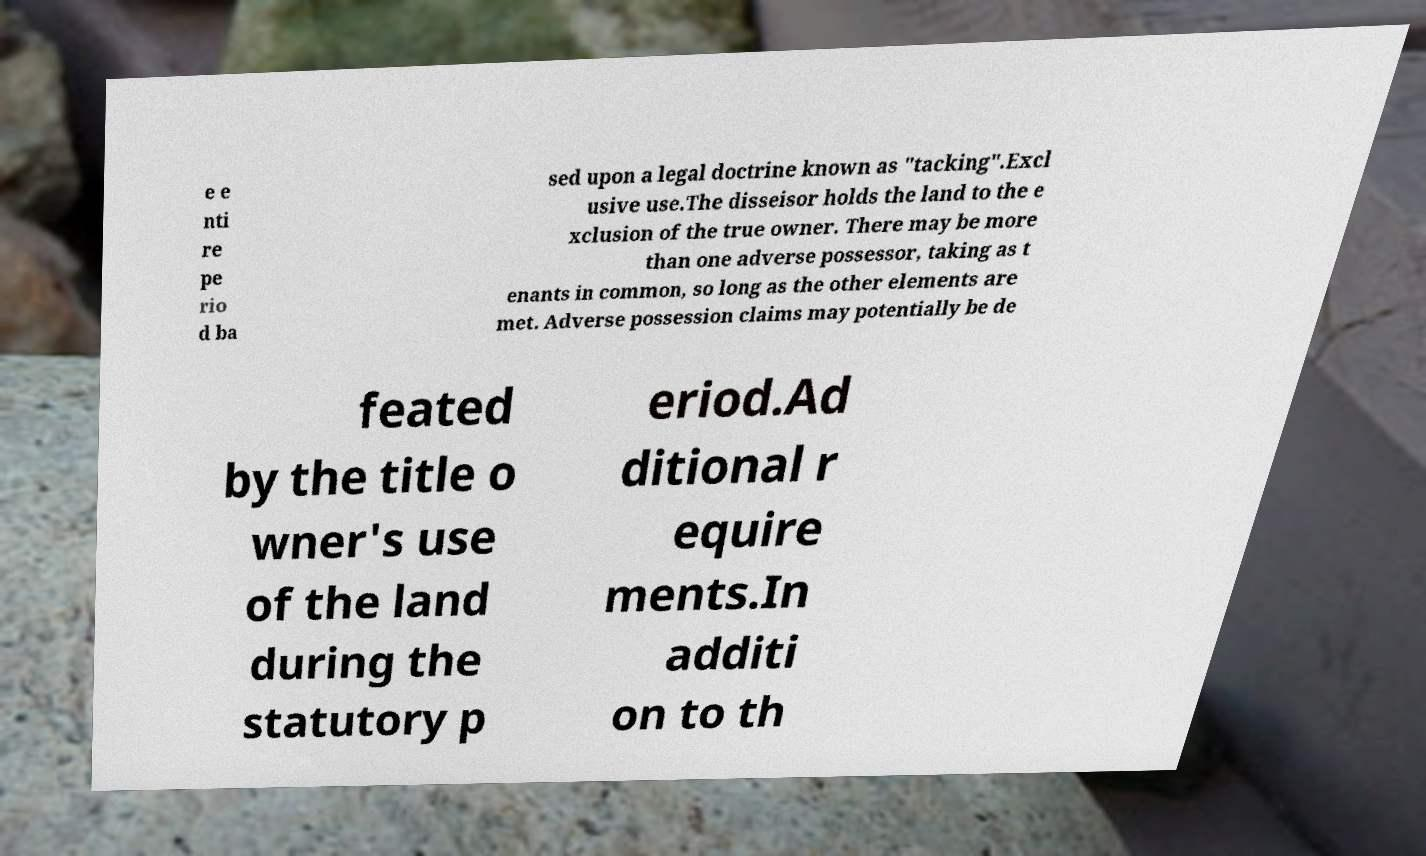Can you accurately transcribe the text from the provided image for me? e e nti re pe rio d ba sed upon a legal doctrine known as "tacking".Excl usive use.The disseisor holds the land to the e xclusion of the true owner. There may be more than one adverse possessor, taking as t enants in common, so long as the other elements are met. Adverse possession claims may potentially be de feated by the title o wner's use of the land during the statutory p eriod.Ad ditional r equire ments.In additi on to th 